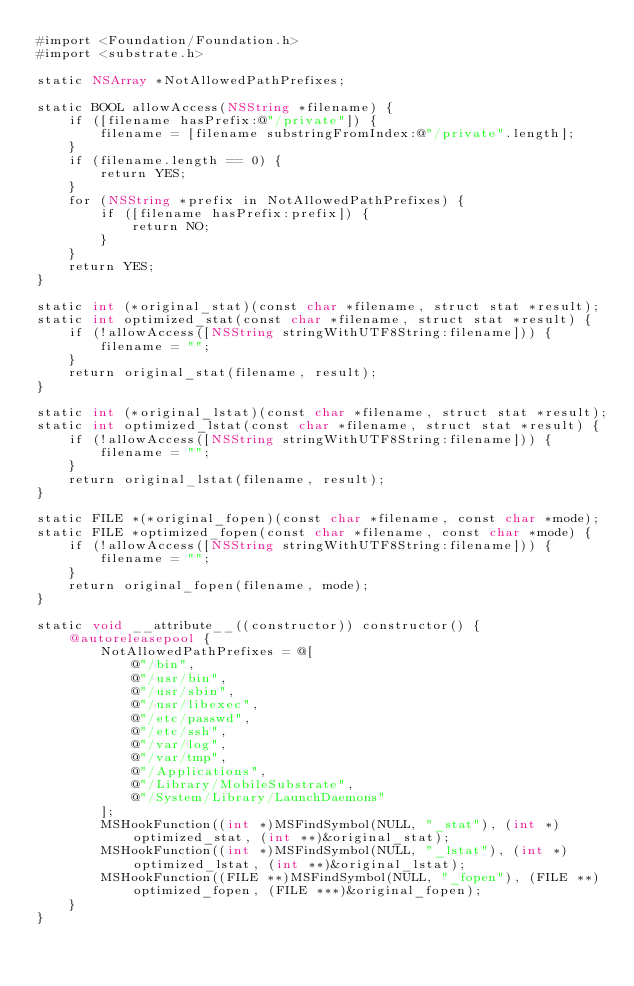<code> <loc_0><loc_0><loc_500><loc_500><_ObjectiveC_>#import <Foundation/Foundation.h>
#import <substrate.h>

static NSArray *NotAllowedPathPrefixes;

static BOOL allowAccess(NSString *filename) {
    if ([filename hasPrefix:@"/private"]) {
        filename = [filename substringFromIndex:@"/private".length];
    }
    if (filename.length == 0) {
        return YES;
    }
    for (NSString *prefix in NotAllowedPathPrefixes) {
        if ([filename hasPrefix:prefix]) {
            return NO;
        }
    }
    return YES;
}

static int (*original_stat)(const char *filename, struct stat *result);
static int optimized_stat(const char *filename, struct stat *result) {
    if (!allowAccess([NSString stringWithUTF8String:filename])) {
        filename = "";
    }
    return original_stat(filename, result);
}

static int (*original_lstat)(const char *filename, struct stat *result);
static int optimized_lstat(const char *filename, struct stat *result) {
    if (!allowAccess([NSString stringWithUTF8String:filename])) {
        filename = "";
    }
    return original_lstat(filename, result);
}

static FILE *(*original_fopen)(const char *filename, const char *mode);
static FILE *optimized_fopen(const char *filename, const char *mode) {
    if (!allowAccess([NSString stringWithUTF8String:filename])) {
        filename = "";
    }
    return original_fopen(filename, mode);
}

static void __attribute__((constructor)) constructor() {
    @autoreleasepool {
        NotAllowedPathPrefixes = @[
            @"/bin",
            @"/usr/bin",
            @"/usr/sbin",
            @"/usr/libexec",
            @"/etc/passwd",
            @"/etc/ssh",
            @"/var/log",
            @"/var/tmp",
            @"/Applications",
            @"/Library/MobileSubstrate",
            @"/System/Library/LaunchDaemons"
        ];
        MSHookFunction((int *)MSFindSymbol(NULL, "_stat"), (int *)optimized_stat, (int **)&original_stat);
        MSHookFunction((int *)MSFindSymbol(NULL, "_lstat"), (int *)optimized_lstat, (int **)&original_lstat);
        MSHookFunction((FILE **)MSFindSymbol(NULL, "_fopen"), (FILE **)optimized_fopen, (FILE ***)&original_fopen);
    }
}
</code> 